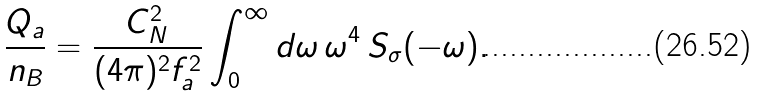Convert formula to latex. <formula><loc_0><loc_0><loc_500><loc_500>\frac { Q _ { a } } { n _ { B } } = \frac { C _ { N } ^ { 2 } } { ( 4 \pi ) ^ { 2 } f _ { a } ^ { 2 } } \int _ { 0 } ^ { \infty } d \omega \, \omega ^ { 4 } \, S _ { \sigma } ( - \omega ) .</formula> 